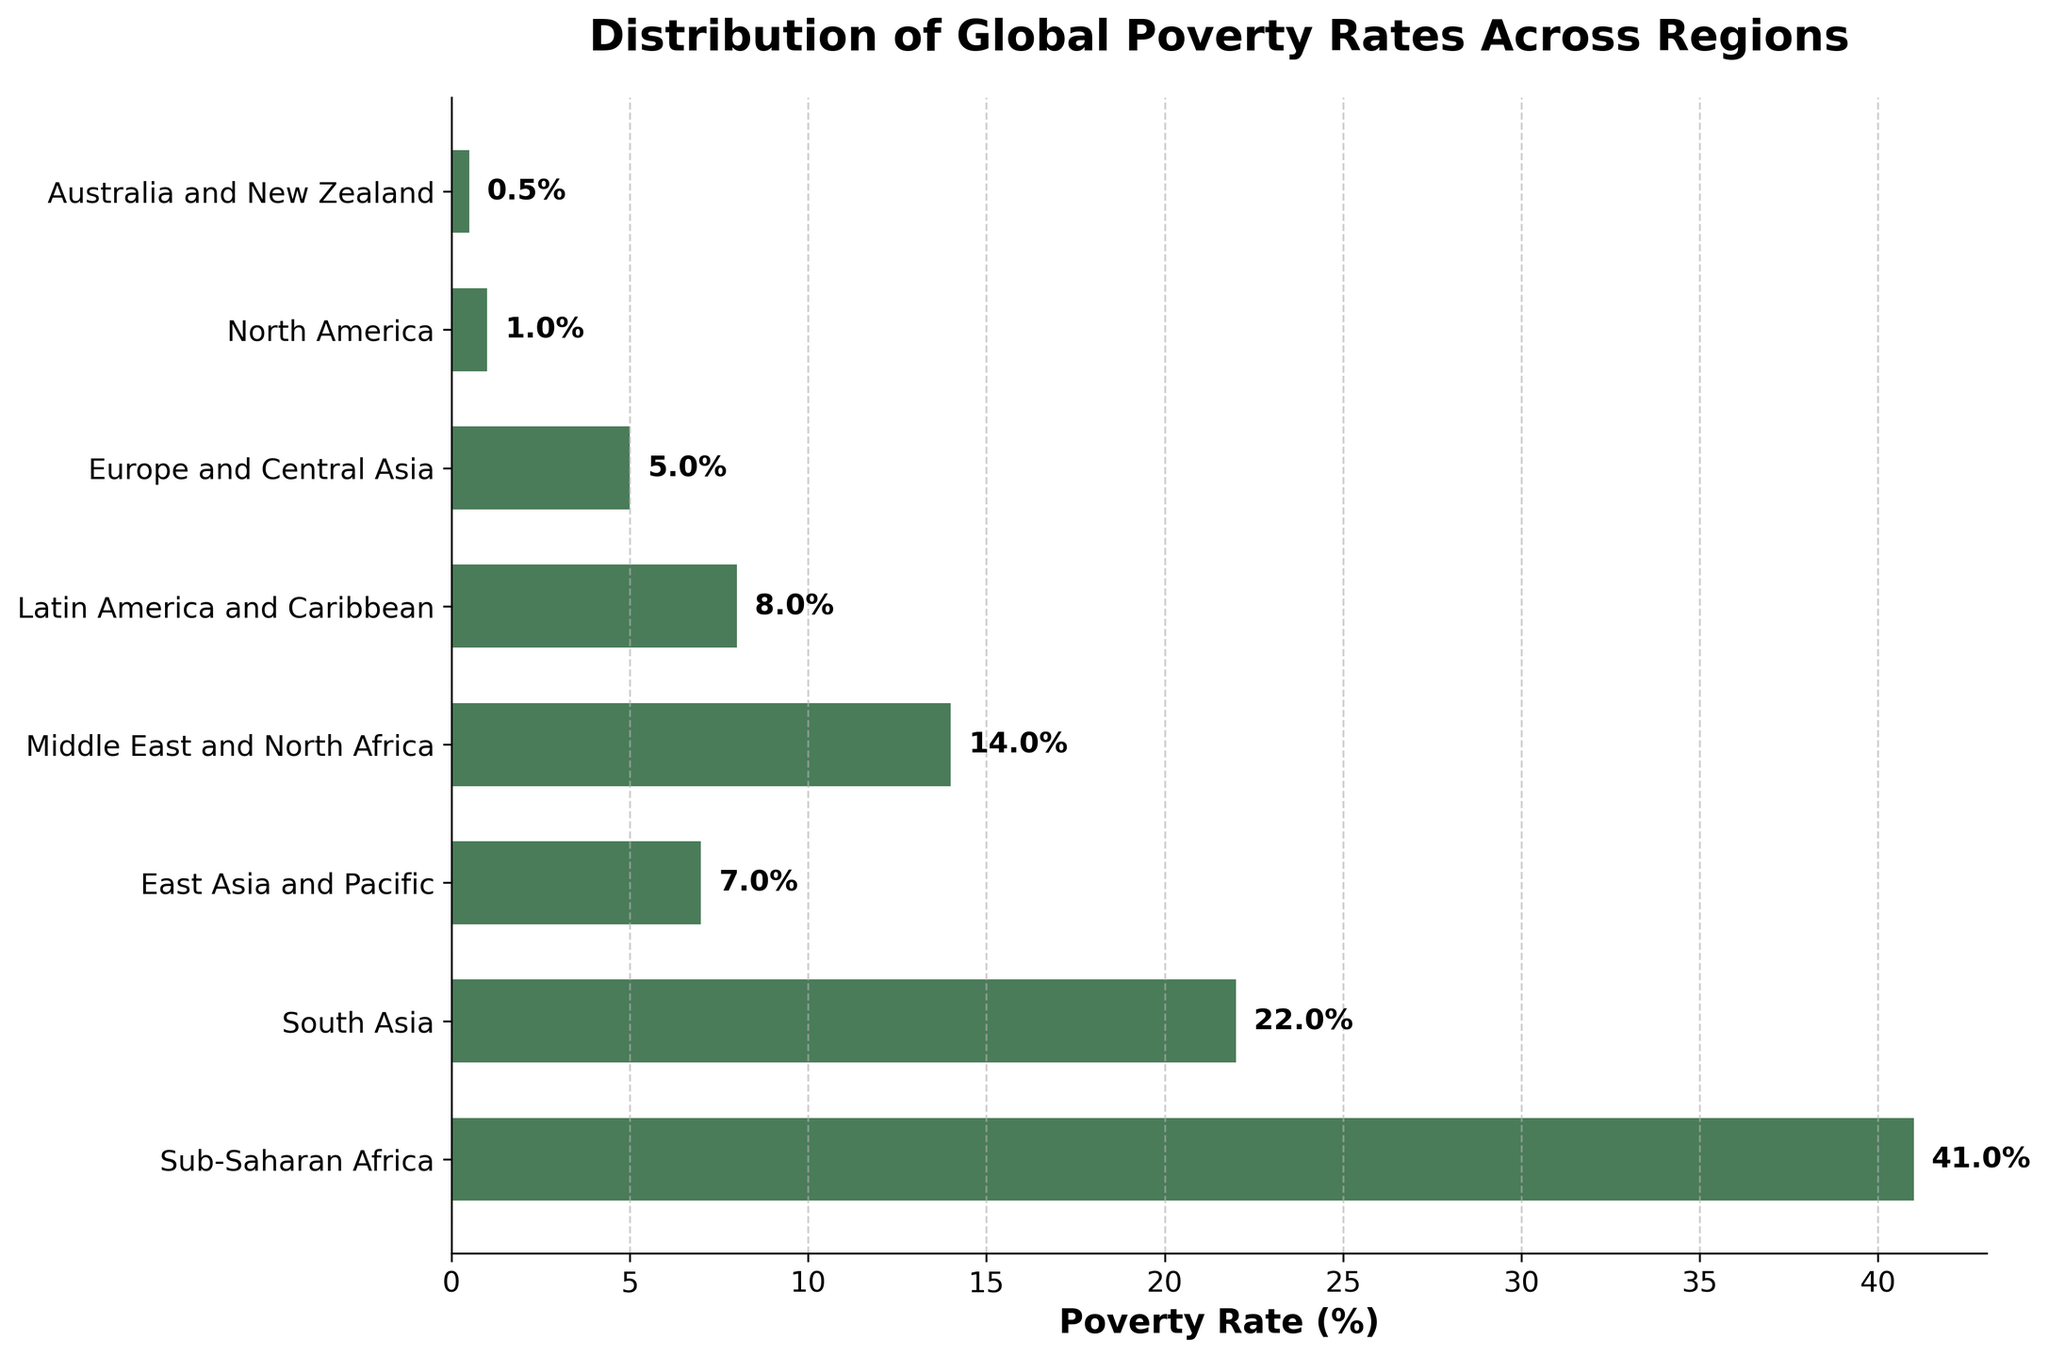What region has the highest poverty rate? The bar representing Sub-Saharan Africa is the longest, indicating the highest poverty rate.
Answer: Sub-Saharan Africa Which region has the lowest poverty rate? The bar representing Australia and New Zealand is the shortest, indicating the lowest poverty rate.
Answer: Australia and New Zealand Compare the poverty rates of South Asia and East Asia and Pacific. Which region has a higher rate and by how much? South Asia has a poverty rate of 22% while East Asia and Pacific has a rate of 7%. 22% - 7% = 15%. South Asia has a higher poverty rate by 15%.
Answer: South Asia by 15% What is the combined average poverty rate of Latin America and Caribbean, Europe and Central Asia, and North America? Adding the rates: 8% (Latin America and Caribbean) + 5% (Europe and Central Asia) + 1% (North America) = 14%. Dividing by the number of regions: 14% / 3 = 4.67%.
Answer: 4.67% How does the poverty rate in the Middle East and North Africa compare to Europe and Central Asia? Middle East and North Africa has a poverty rate of 14%, which is higher than Europe and Central Asia's rate of 5%. 14% - 5% = 9%. The Middle East and North Africa has a higher poverty rate by 9%.
Answer: Middle East and North Africa by 9% What is the difference in poverty rates between the region with the highest and the lowest rates? The highest rate is in Sub-Saharan Africa (41%) and the lowest is in Australia and New Zealand (0.5%). 41% - 0.5% = 40.5%. The difference is 40.5%.
Answer: 40.5% Which regions have a poverty rate higher than 10%? Sub-Saharan Africa (41%), South Asia (22%), and Middle East and North Africa (14%) have bars extending beyond the 10% mark.
Answer: Sub-Saharan Africa, South Asia, Middle East and North Africa What is the sum of the poverty rates for all regions shown? Sum of all the rates: 41% (Sub-Saharan Africa) + 22% (South Asia) + 7% (East Asia and Pacific) + 14% (Middle East and North Africa) + 8% (Latin America and Caribbean) + 5% (Europe and Central Asia) + 1% (North America) + 0.5% (Australia and New Zealand) = 98.5%.
Answer: 98.5% Are there more regions with a poverty rate below 10% or above 10%? Below 10%: East Asia and Pacific, Latin America and Caribbean, Europe and Central Asia, North America, Australia and New Zealand (5 regions). Above 10%: Sub-Saharan Africa, South Asia, Middle East and North Africa (3 regions). There are more regions with a poverty rate below 10%.
Answer: Below 10% Among the regions listed, which one has the median poverty rate, and what is that rate? Arrange the rates in ascending order: 0.5%, 1%, 5%, 7%, 8%, 14%, 22%, 41%. The median is the average of the 4th and 5th values: (7% + 8%) / 2 = 7.5%. The regions East Asia and Pacific and Latin America and Caribbean have the median poverty rate.
Answer: 7.5% 